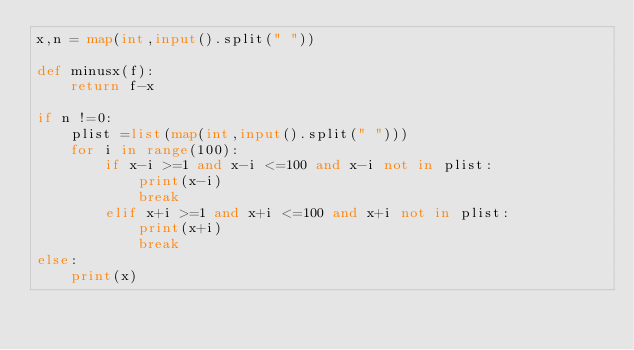<code> <loc_0><loc_0><loc_500><loc_500><_Python_>x,n = map(int,input().split(" "))

def minusx(f):
    return f-x

if n !=0:
    plist =list(map(int,input().split(" ")))
    for i in range(100):
        if x-i >=1 and x-i <=100 and x-i not in plist:
            print(x-i)
            break
        elif x+i >=1 and x+i <=100 and x+i not in plist:
            print(x+i)
            break
else:
    print(x)</code> 